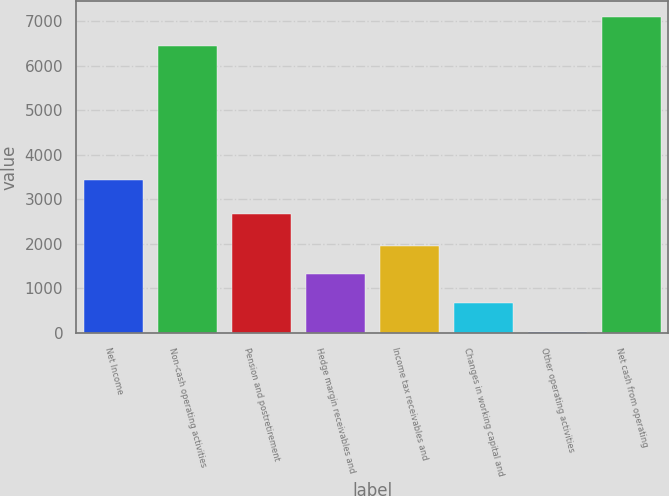Convert chart to OTSL. <chart><loc_0><loc_0><loc_500><loc_500><bar_chart><fcel>Net Income<fcel>Non-cash operating activities<fcel>Pension and postretirement<fcel>Hedge margin receivables and<fcel>Income tax receivables and<fcel>Changes in working capital and<fcel>Other operating activities<fcel>Net cash from operating<nl><fcel>3431<fcel>6444<fcel>2668<fcel>1314.6<fcel>1959.4<fcel>669.8<fcel>25<fcel>7088.8<nl></chart> 